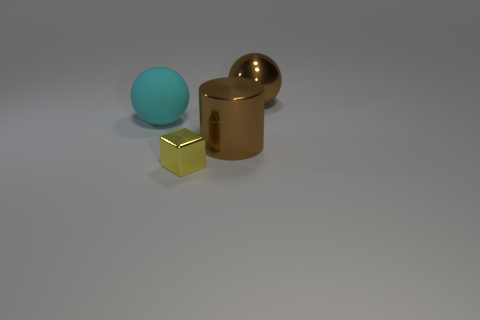What number of objects are either large brown metal blocks or big metal objects that are behind the big brown cylinder?
Your response must be concise. 1. Is the size of the shiny cylinder the same as the brown shiny sphere?
Your response must be concise. Yes. Are there any shiny spheres left of the large brown shiny sphere?
Provide a short and direct response. No. What is the size of the object that is both behind the brown metallic cylinder and on the right side of the rubber object?
Your answer should be very brief. Large. What number of objects are cyan things or small yellow blocks?
Your answer should be compact. 2. There is a block; is it the same size as the brown shiny thing in front of the big cyan matte thing?
Provide a short and direct response. No. There is a thing that is to the left of the thing in front of the large brown object that is left of the metal ball; what size is it?
Keep it short and to the point. Large. Is there a blue metallic cube?
Your answer should be very brief. No. There is a large ball that is the same color as the big shiny cylinder; what is its material?
Ensure brevity in your answer.  Metal. How many big matte balls have the same color as the metallic cylinder?
Make the answer very short. 0. 